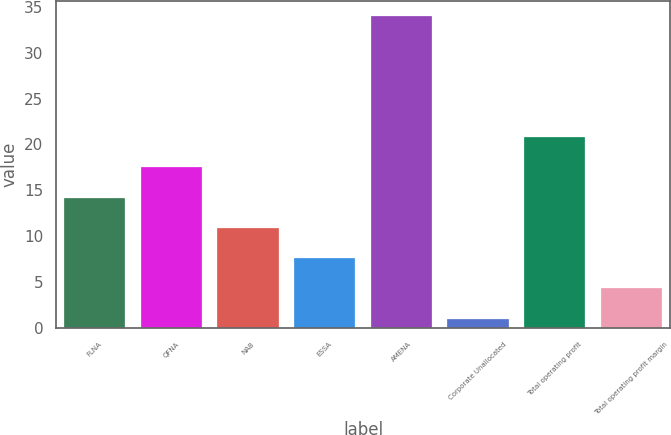Convert chart. <chart><loc_0><loc_0><loc_500><loc_500><bar_chart><fcel>FLNA<fcel>QFNA<fcel>NAB<fcel>ESSA<fcel>AMENA<fcel>Corporate Unallocated<fcel>Total operating profit<fcel>Total operating profit margin<nl><fcel>14.2<fcel>17.5<fcel>10.9<fcel>7.6<fcel>34<fcel>1<fcel>20.8<fcel>4.3<nl></chart> 